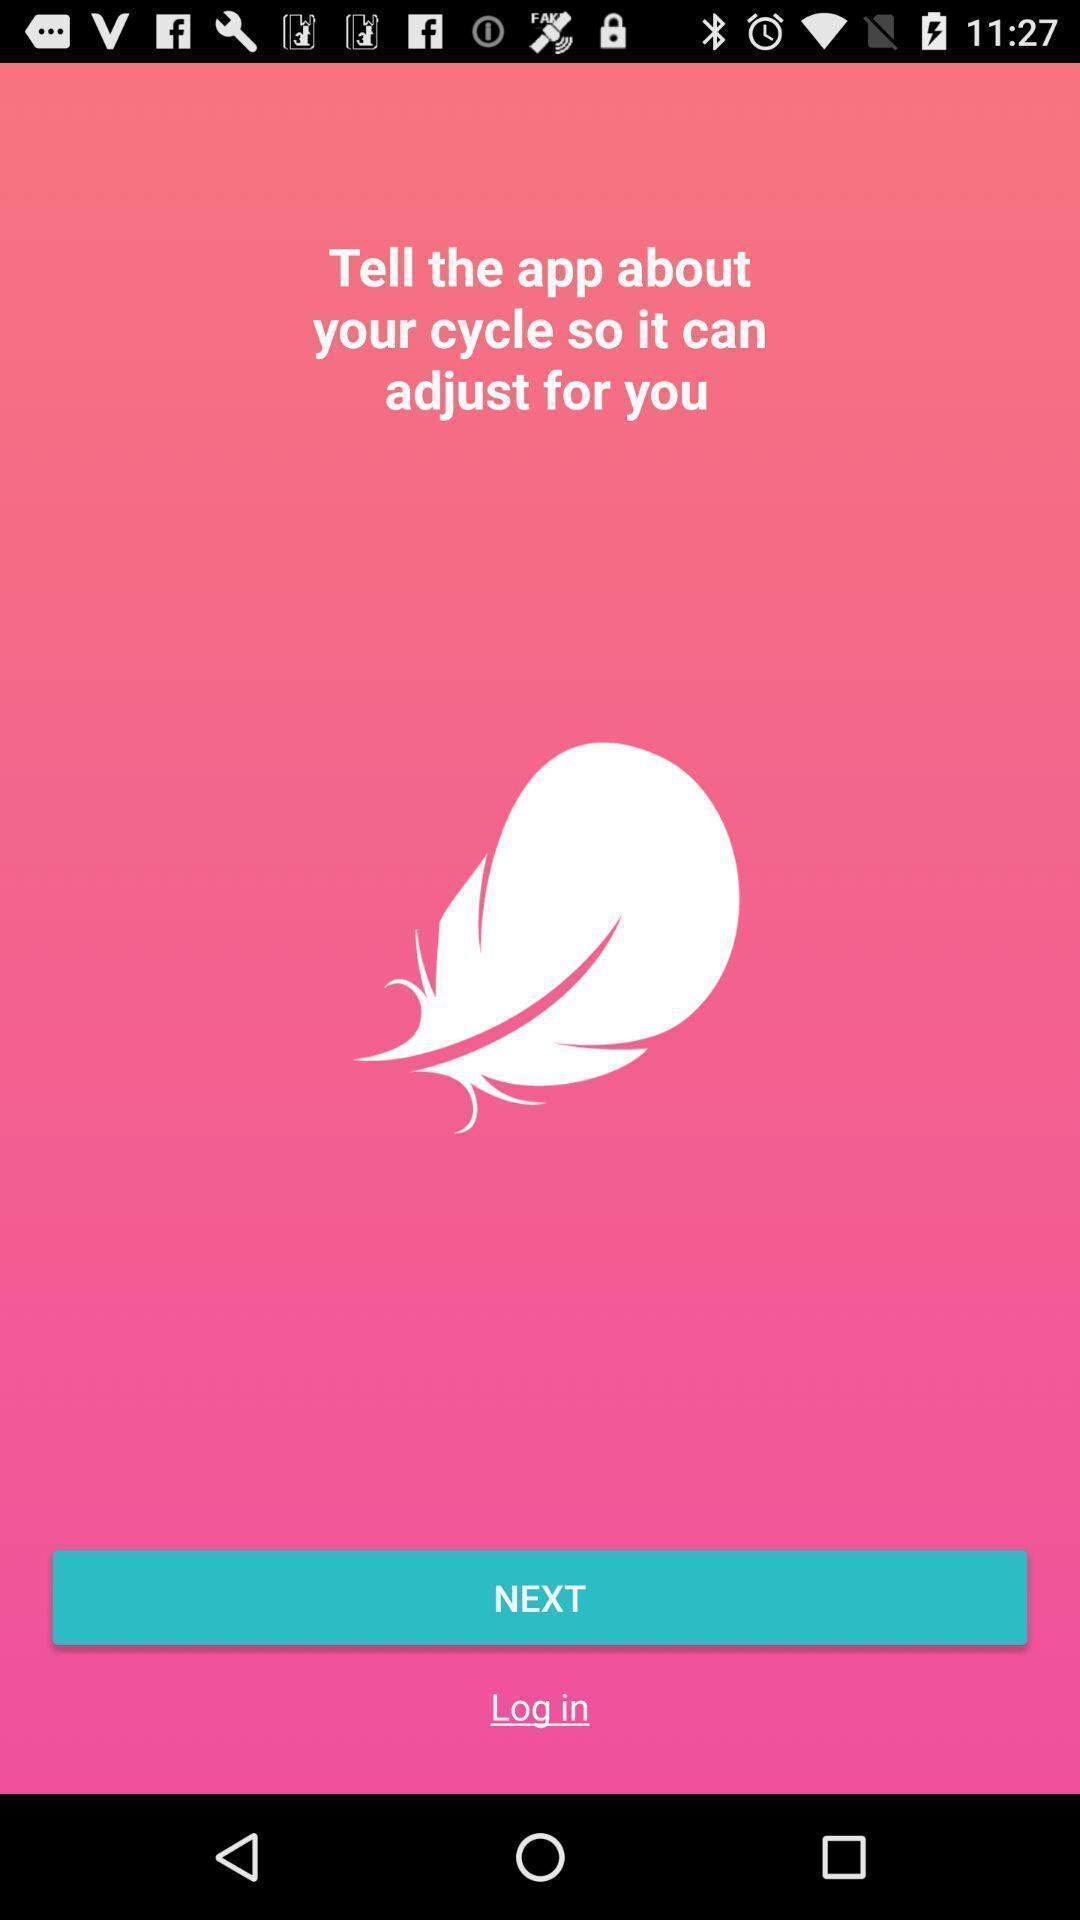Summarize the main components in this picture. Welcome page. 